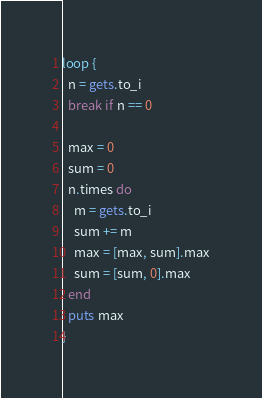<code> <loc_0><loc_0><loc_500><loc_500><_Ruby_>loop {
  n = gets.to_i
  break if n == 0

  max = 0
  sum = 0
  n.times do
    m = gets.to_i
    sum += m
    max = [max, sum].max
    sum = [sum, 0].max
  end
  puts max
}</code> 